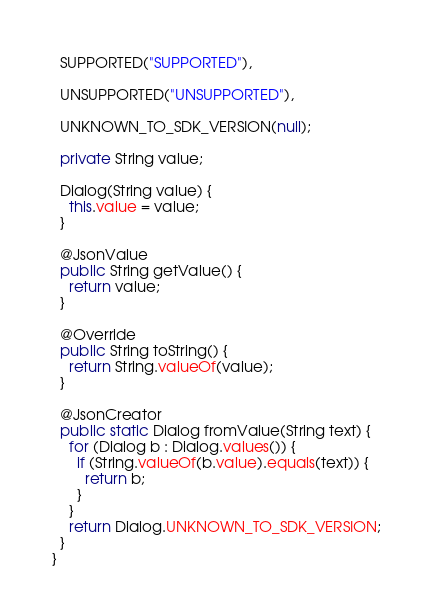<code> <loc_0><loc_0><loc_500><loc_500><_Java_>  SUPPORTED("SUPPORTED"),
  
  UNSUPPORTED("UNSUPPORTED"),
  
  UNKNOWN_TO_SDK_VERSION(null);

  private String value;

  Dialog(String value) {
    this.value = value;
  }

  @JsonValue
  public String getValue() {
    return value;
  }

  @Override
  public String toString() {
    return String.valueOf(value);
  }

  @JsonCreator
  public static Dialog fromValue(String text) {
    for (Dialog b : Dialog.values()) {
      if (String.valueOf(b.value).equals(text)) {
        return b;
      }
    }
    return Dialog.UNKNOWN_TO_SDK_VERSION;
  }
}

</code> 